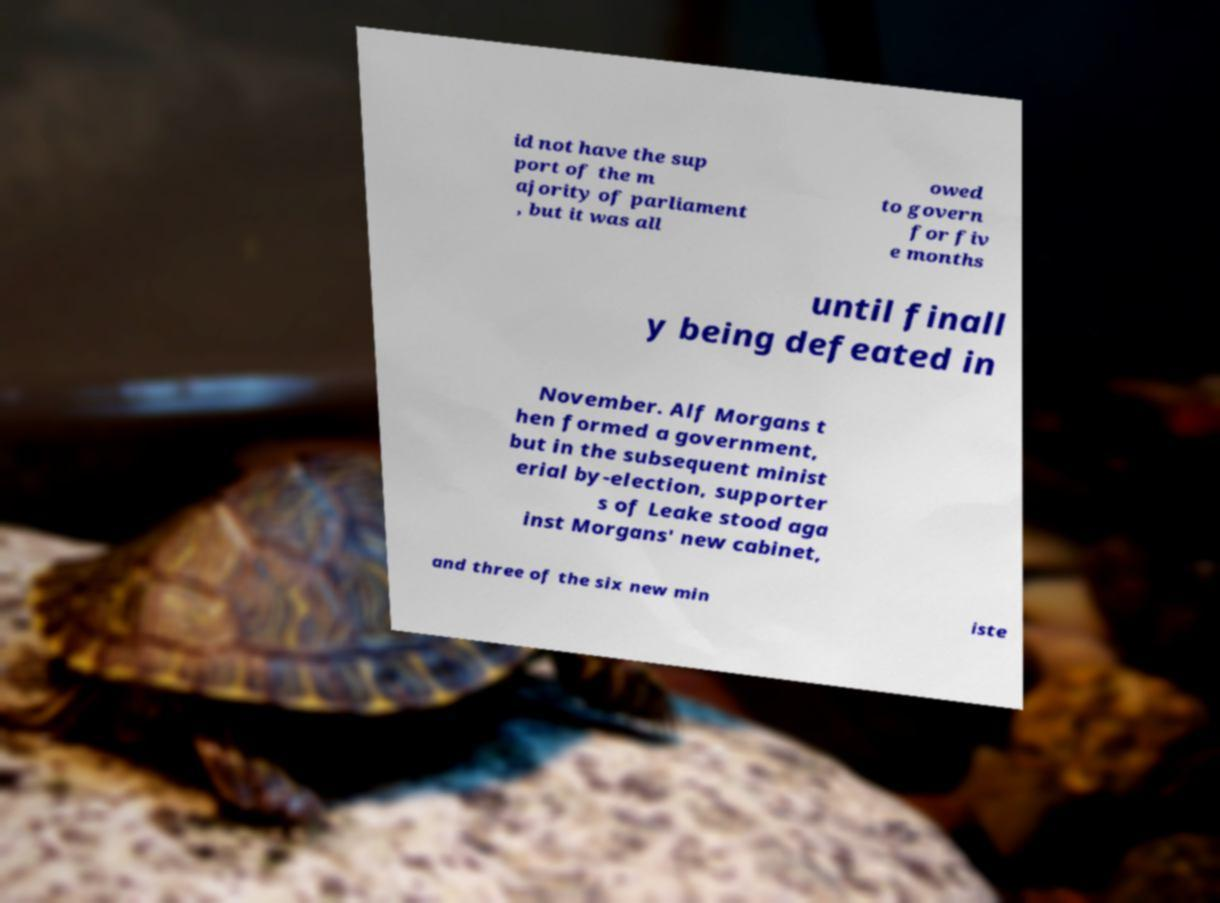Please read and relay the text visible in this image. What does it say? id not have the sup port of the m ajority of parliament , but it was all owed to govern for fiv e months until finall y being defeated in November. Alf Morgans t hen formed a government, but in the subsequent minist erial by-election, supporter s of Leake stood aga inst Morgans' new cabinet, and three of the six new min iste 